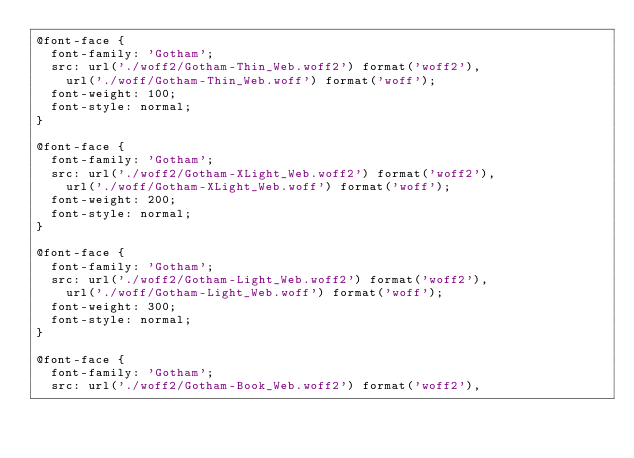<code> <loc_0><loc_0><loc_500><loc_500><_CSS_>@font-face {
  font-family: 'Gotham';
  src: url('./woff2/Gotham-Thin_Web.woff2') format('woff2'),
    url('./woff/Gotham-Thin_Web.woff') format('woff');
  font-weight: 100;
  font-style: normal;
}

@font-face {
  font-family: 'Gotham';
  src: url('./woff2/Gotham-XLight_Web.woff2') format('woff2'),
    url('./woff/Gotham-XLight_Web.woff') format('woff');
  font-weight: 200;
  font-style: normal;
}

@font-face {
  font-family: 'Gotham';
  src: url('./woff2/Gotham-Light_Web.woff2') format('woff2'),
    url('./woff/Gotham-Light_Web.woff') format('woff');
  font-weight: 300;
  font-style: normal;
}

@font-face {
  font-family: 'Gotham';
  src: url('./woff2/Gotham-Book_Web.woff2') format('woff2'),</code> 